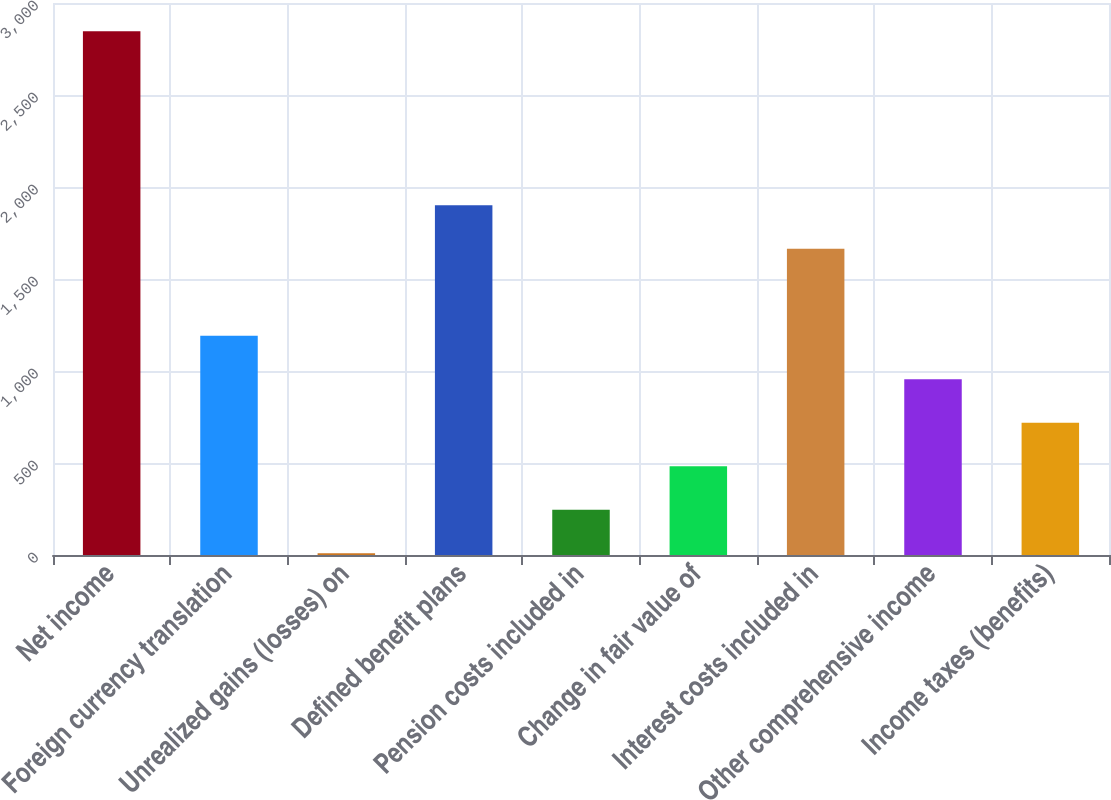Convert chart to OTSL. <chart><loc_0><loc_0><loc_500><loc_500><bar_chart><fcel>Net income<fcel>Foreign currency translation<fcel>Unrealized gains (losses) on<fcel>Defined benefit plans<fcel>Pension costs included in<fcel>Change in fair value of<fcel>Interest costs included in<fcel>Other comprehensive income<fcel>Income taxes (benefits)<nl><fcel>2845.8<fcel>1191<fcel>9<fcel>1900.2<fcel>245.4<fcel>481.8<fcel>1663.8<fcel>954.6<fcel>718.2<nl></chart> 